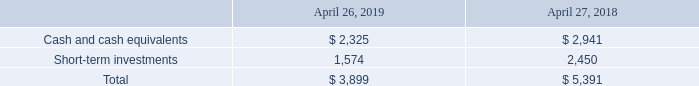Liquidity
Our principal sources of liquidity as of April 26, 2019 consisted of cash, cash equivalents and short-term investments, cash we expect to generate from operations, and our commercial paper program and related credit facility.
Cash, cash equivalents and short-term investments consisted of the following (in millions):
As of April 26, 2019 and April 27, 2018, $3.7 billion and $4.5 billion, respectively, of cash, cash equivalents and short-term investments were held by various foreign subsidiaries and were generally based in U.S. dollar-denominated holdings, while $0.2 billion and $0.9 billion, respectively, were available in the U.S. The TCJA imposes a one-time transition tax on substantially all accumulated foreign earnings through December 31, 2017, and generally allows companies to make distributions of foreign earnings without incurring additional federal taxes. As a part of the recognition of the impacts of the TCJA, we have reviewed our projected global cash requirements and have determined that certain historical and future foreign earnings will no longer be indefinitely reinvested.
Our principal liquidity requirements are primarily to meet our working capital needs, support ongoing business activities, fund research and development, meet capital expenditure needs, invest in critical or complementary technologies, service interest and principal payments on our debt, fund our stock repurchase program, and pay dividends, as and if declared.
The principal objectives of our investment policy are the preservation of principal and maintenance of liquidity. We attempt to mitigate default risk by investing in high-quality investment grade securities, limiting the time to maturity and monitoring the counter-parties and underlying obligors closely. We believe our cash equivalents and short-term investments are liquid and accessible. We are not aware of any significant deterioration in the fair value of our cash equivalents or investments from the values reported as of April 26, 2019.
Our investment portfolio has been and will continue to be exposed to market risk due to trends in the credit and capital markets. We continue to closely monitor current economic and market events to minimize the market risk of our investment portfolio. We routinely monitor our financial exposure to both sovereign and non-sovereign borrowers and counterparties. We utilize a variety of planning and financing strategies in an effort to ensure our worldwide cash is available when and where it is needed. Based on past performance and current expectations, we believe our cash and cash equivalents, investments, cash generated from operations, and ability to access capital markets and committed credit lines will satisfy, through at least the next 12 months, our liquidity requirements, both in total and domestically, including the following: working capital needs, capital expenditures, stock repurchases, cash dividends, contractual obligations, commitments, principal and interest payments on debt, and other liquidity requirements associated with our operations. We also have an automatic shelf registration statement on file with the Securities and Exchange Commission (SEC). We may in the future offer an additional unspecified amount of debt, equity and other securities.
What were the short-term investments in 2018?
Answer scale should be: million. 2,450. How much cash, cash equivalents and short-term investments were held by various foreign subsidiaries in 2019? $3.7 billion. What was the total cash, cash equivalents and short-term investments in 2019?
Answer scale should be: million. 3,899. What was the change in short-term investments between 2018 and 2019?
Answer scale should be: million. 1,574-2,450
Answer: -876. How many years did the total of cash and cash equivalents and short-term investments exceed $4,000 million? 2018
Answer: 1. What was the percentage change in cash and cash equivalents between 2018 and 2019?
Answer scale should be: percent. (2,325-2,941)/2,941
Answer: -20.95. 